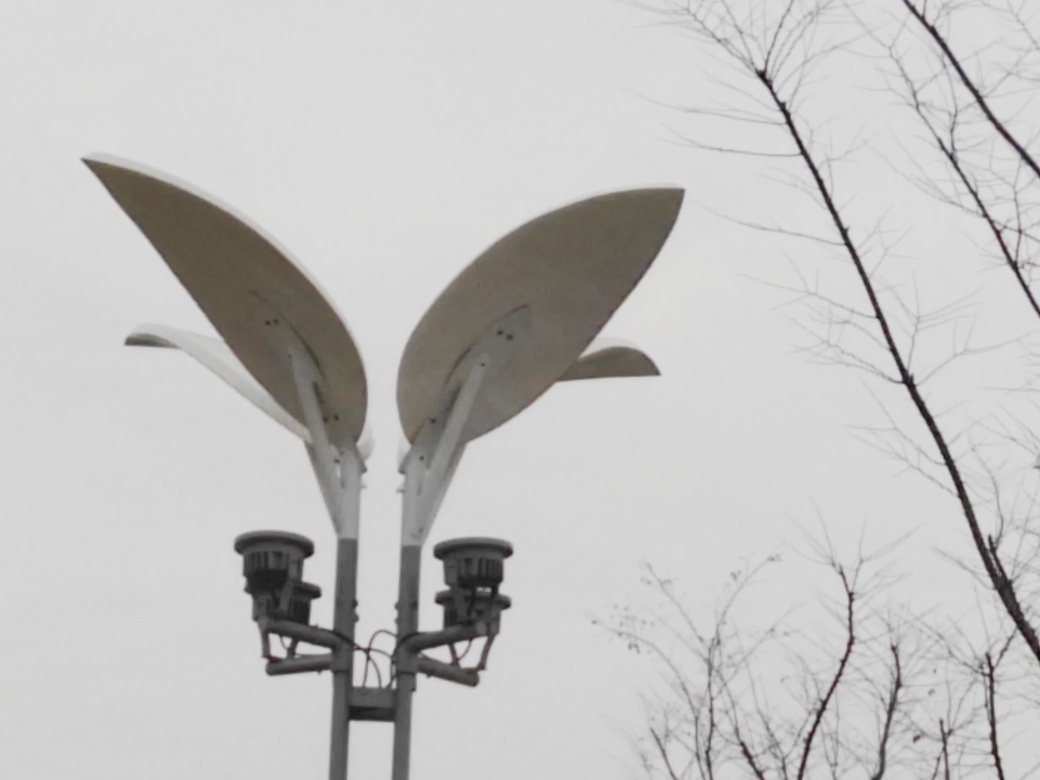What is the mood conveyed by this image, and how does the color scheme contribute to it? The image exudes a tranquil and somewhat somber mood. The predominance of gray tones and the overcast sky evoke feelings of calmness and stillness, with the absence of bright colors reinforcing a subtle sense of melancholy. The image's subdued color scheme is integral to this atmosphere, suggesting a quiet, perhaps chilly day. 